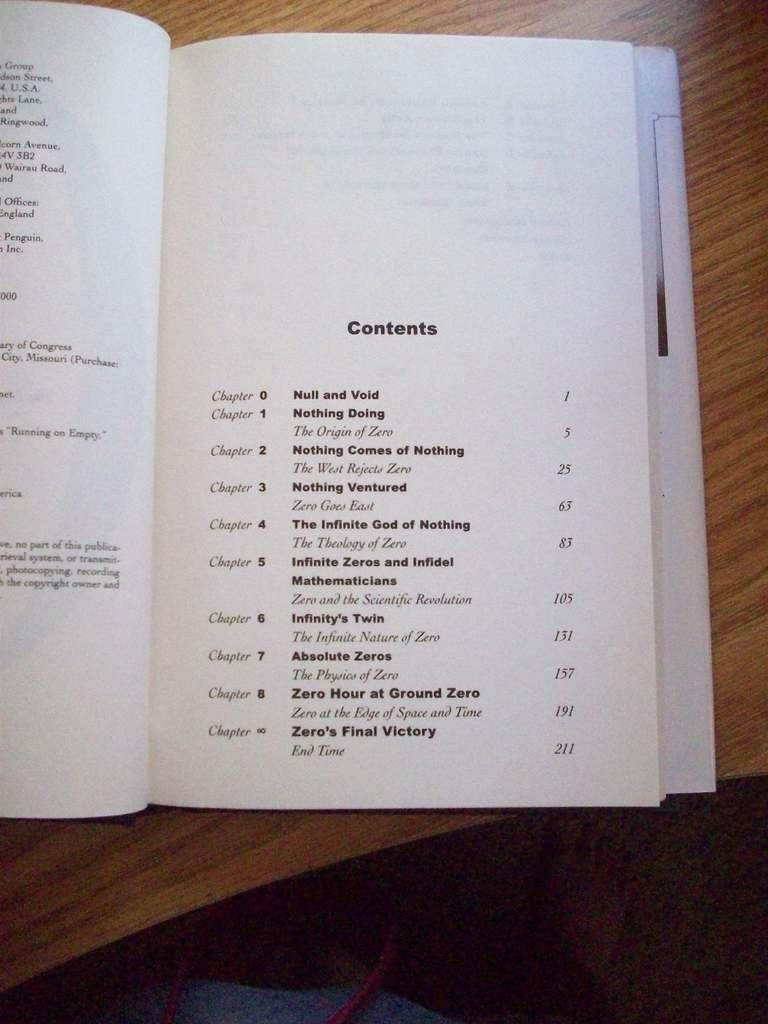Provide a one-sentence caption for the provided image. A book laying on a table opened up to the Contents page. 